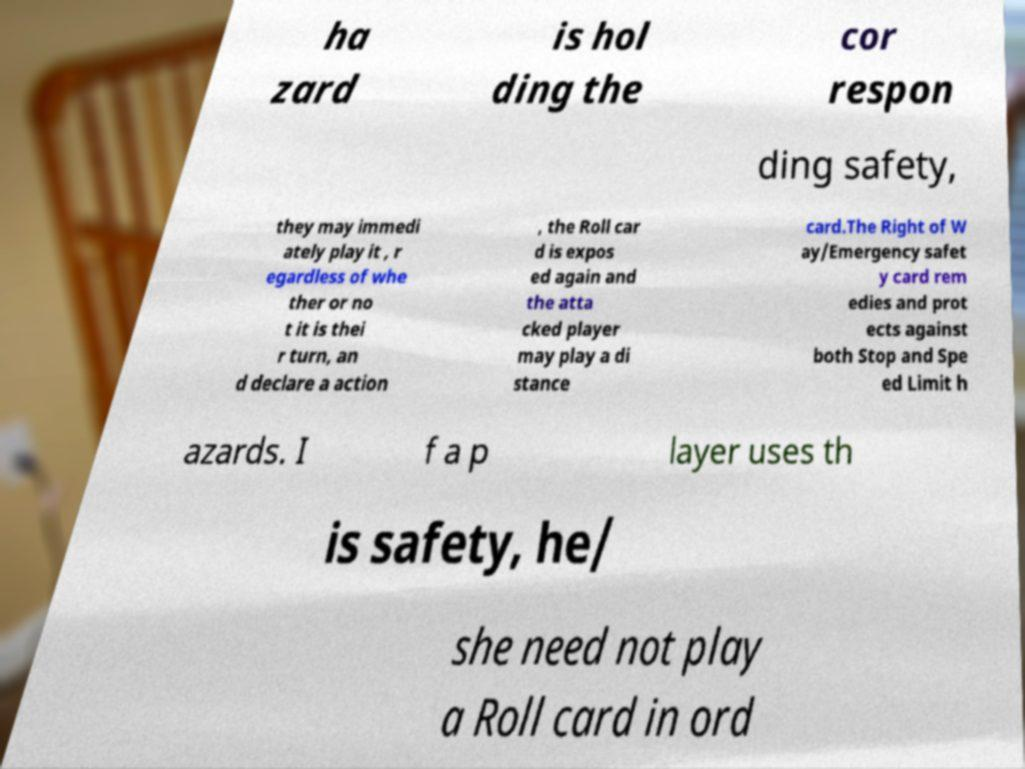Please read and relay the text visible in this image. What does it say? ha zard is hol ding the cor respon ding safety, they may immedi ately play it , r egardless of whe ther or no t it is thei r turn, an d declare a action , the Roll car d is expos ed again and the atta cked player may play a di stance card.The Right of W ay/Emergency safet y card rem edies and prot ects against both Stop and Spe ed Limit h azards. I f a p layer uses th is safety, he/ she need not play a Roll card in ord 